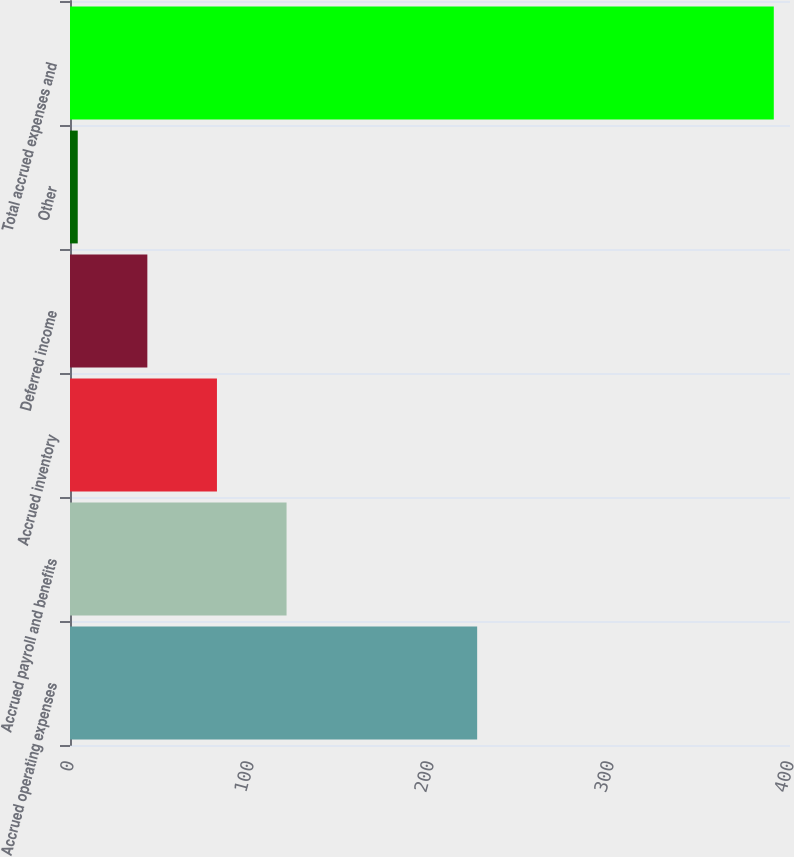<chart> <loc_0><loc_0><loc_500><loc_500><bar_chart><fcel>Accrued operating expenses<fcel>Accrued payroll and benefits<fcel>Accrued inventory<fcel>Deferred income<fcel>Other<fcel>Total accrued expenses and<nl><fcel>226.2<fcel>120.31<fcel>81.64<fcel>42.97<fcel>4.3<fcel>391<nl></chart> 